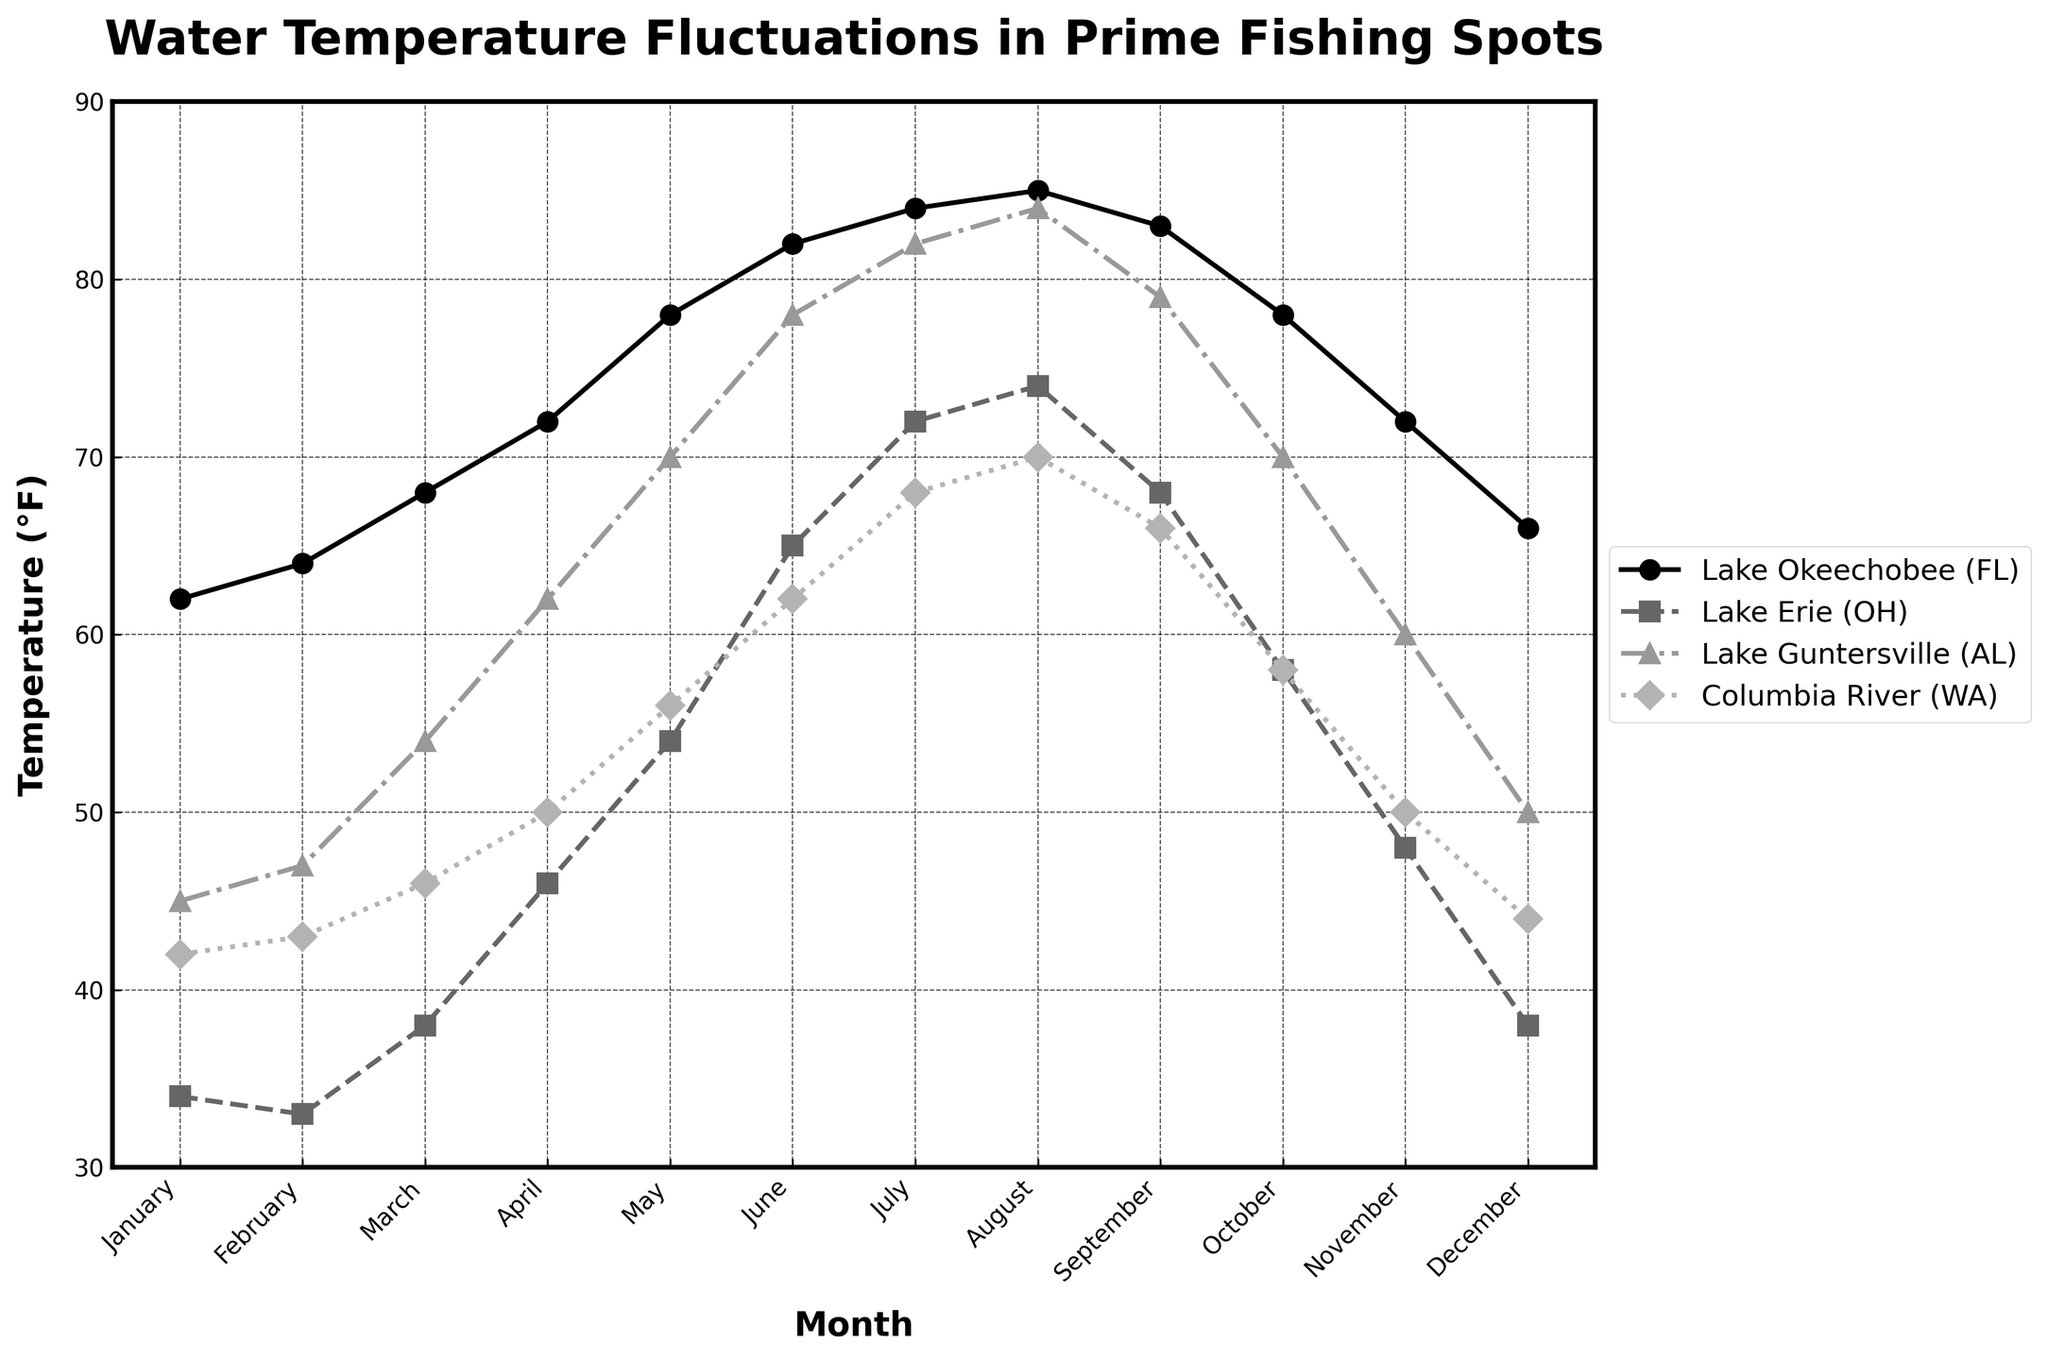What is the highest water temperature recorded at Lake Okeechobee (FL) and in which month does it occur? The highest water temperature recorded at Lake Okeechobee (FL) is observed in August. The temperature for that month is shown as 85°F.
Answer: 85°F in August Which lake has the lowest water temperature in February? Compare the water temperatures in February for all lakes: Lake Okeechobee (FL) at 64°F, Lake Erie (OH) at 33°F, Lake Guntersville (AL) at 47°F, and Columbia River (WA) at 43°F. Lake Erie (OH) has the lowest temperature.
Answer: Lake Erie (OH) How much does the water temperature at Lake Guntersville (AL) increase between January and August? The temperature in January is 45°F and in August is 84°F at Lake Guntersville (AL). The increase is 84°F - 45°F = 39°F.
Answer: 39°F During which month does Lake Erie (OH) experience the largest temperature increase compared to the previous month? Calculate the temperature increase month by month: January to February (-1°F), February to March (+5°F), March to April (+8°F), April to May (+8°F), May to June (+11°F), June to July (+7°F), July to August (+2°F), August to September (-6°F), September to October (-10°F), October to November (-10°F), and November to December (-10°F). The largest increase, +11°F, occurs from May to June.
Answer: June Which lake experiences the smallest temperature range over the year and what is this range? Calculate the range (maximum temperature minus minimum temperature) for each lake: 
Lake Okeechobee (FL): 85°F - 62°F = 23°F,
Lake Erie (OH): 74°F - 33°F = 41°F,
Lake Guntersville (AL): 84°F - 45°F = 39°F,
Columbia River (WA): 70°F - 42°F = 28°F.
The smallest range is 23°F for Lake Okeechobee (FL).
Answer: Lake Okeechobee (FL), 23°F What is the average water temperature for Columbia River (WA) in the months of July, August, and September? Sum the temperatures for the Columbia River (WA) in July (68°F), August (70°F), and September (66°F) and divide by 3: (68 + 70 + 66) / 3 = 68°F.
Answer: 68°F How much warmer is Lake Okeechobee (FL) in December compared to Lake Erie (OH) in the same month? The temperature for Lake Okeechobee (FL) in December is 66°F and for Lake Erie (OH) in December is 38°F. The difference is 66°F - 38°F = 28°F.
Answer: 28°F During which month does all four lakes have their water temperature exceed 50°F simultaneously? Identify the month where all recorded temperatures are greater than 50°F. The only month where Lake Okeechobee (FL): 78°F, Lake Erie (OH): 54°F, Lake Guntersville (AL): 70°F, and Columbia River (WA): 56°F all exceed 50°F is May.
Answer: May 